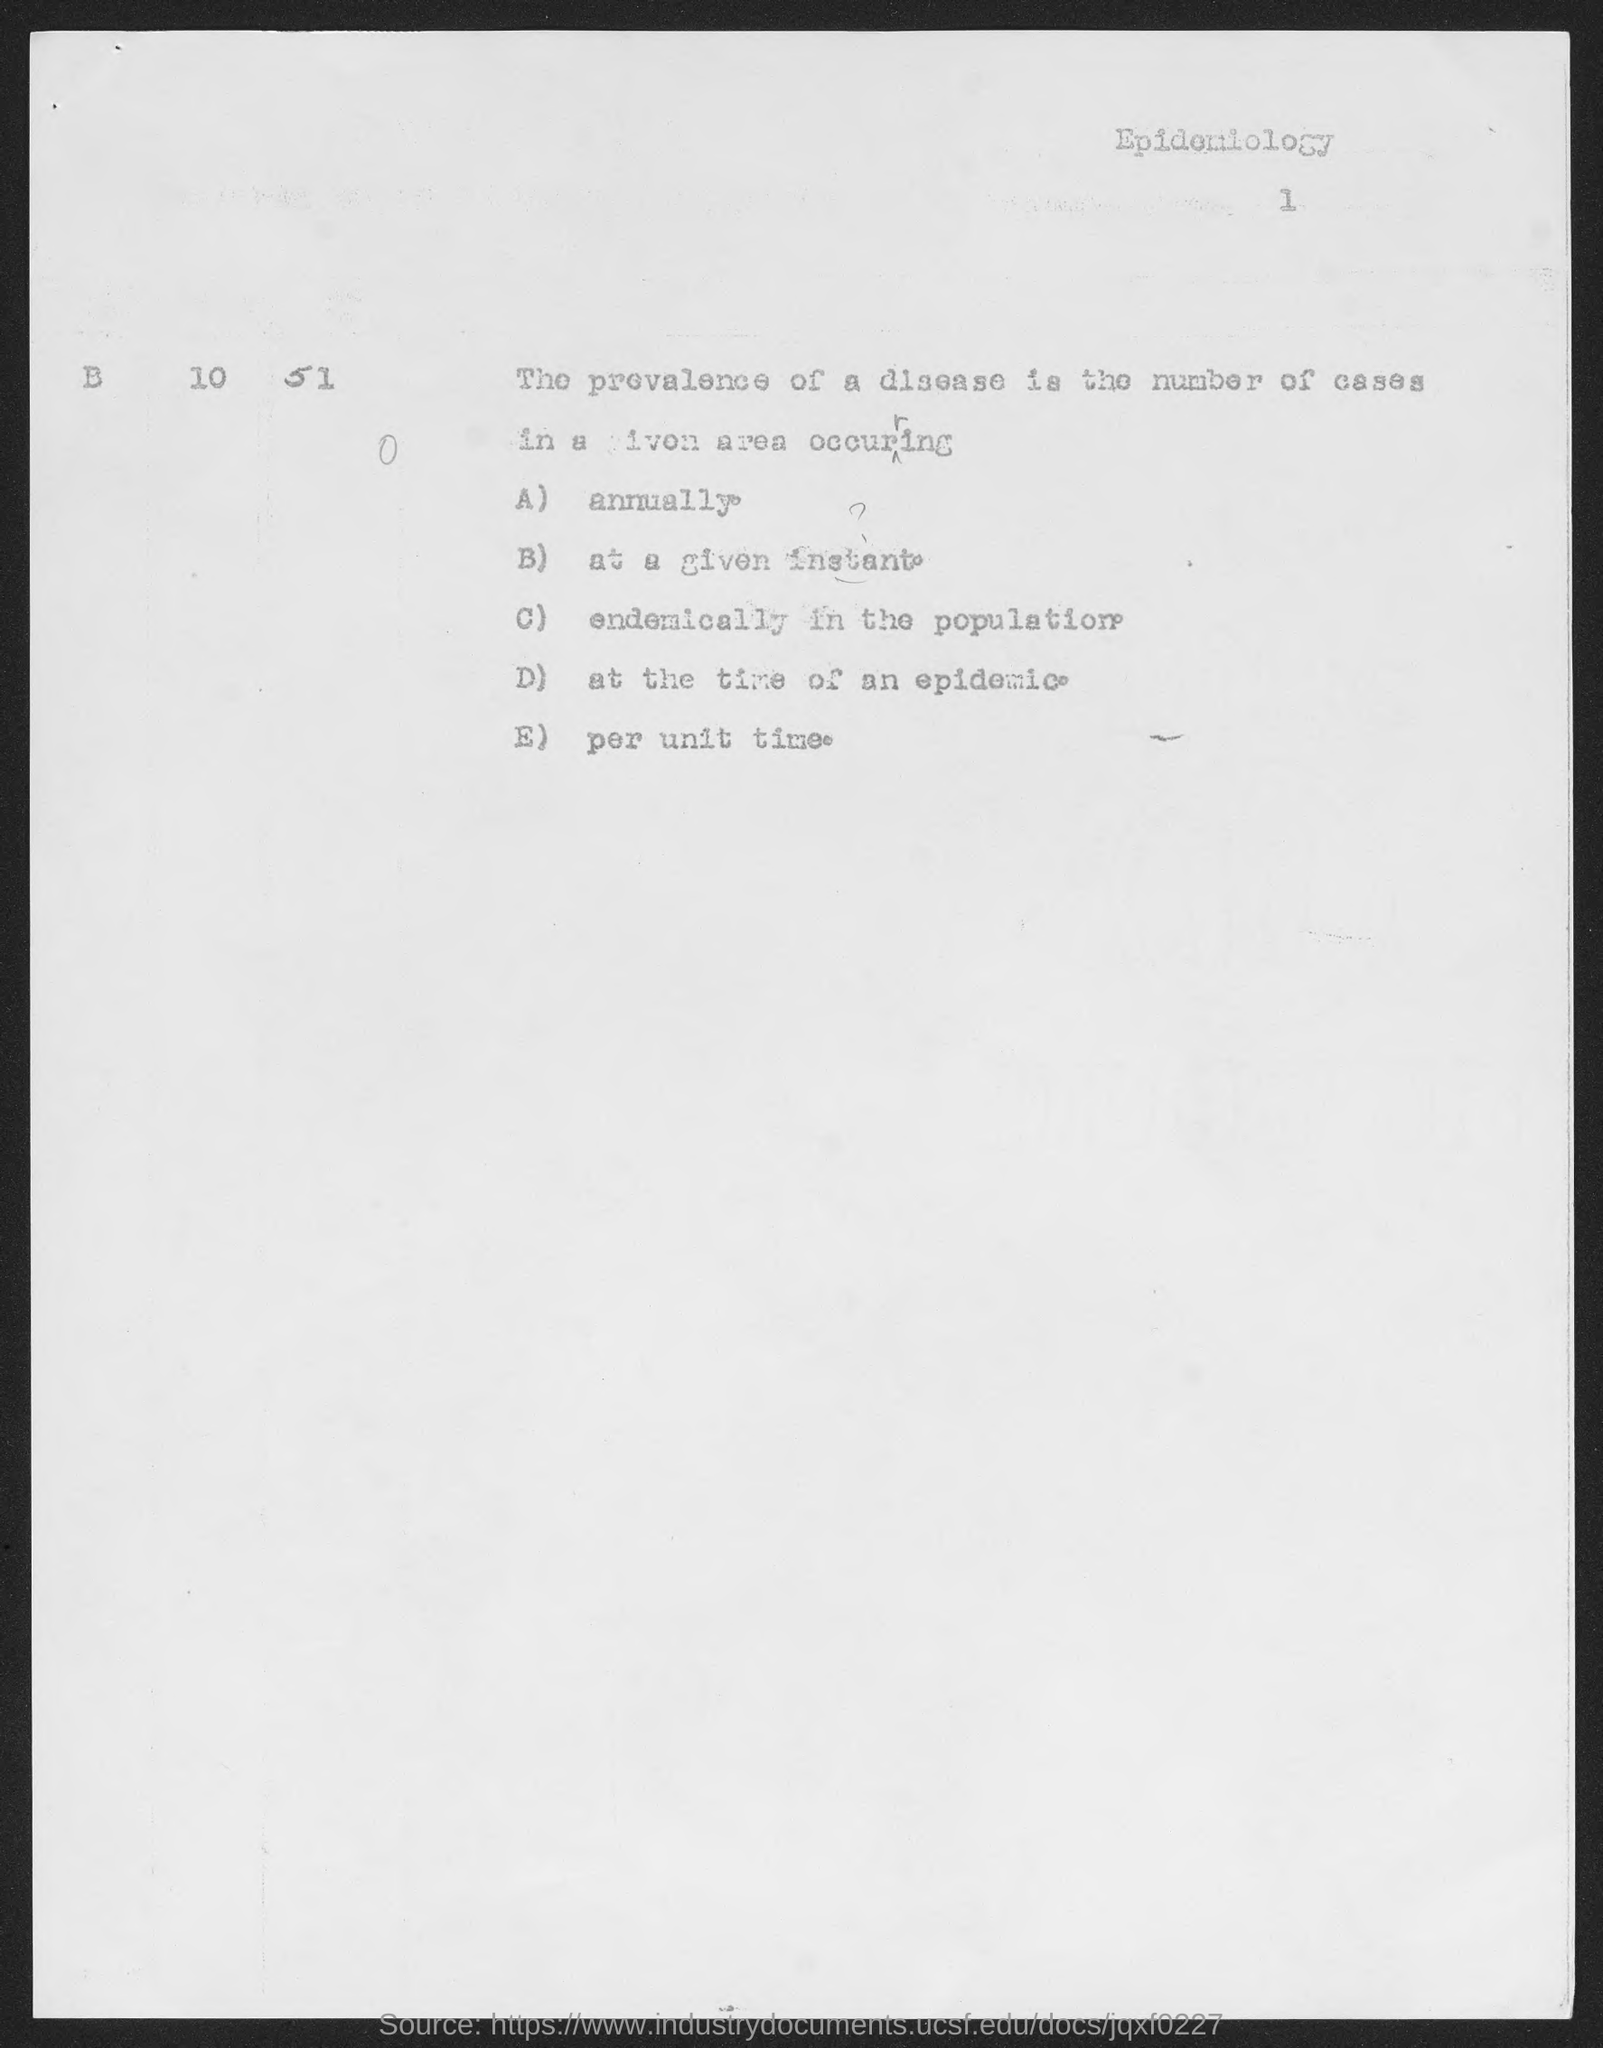What is option 'a'?
Make the answer very short. Annually. What is the subject name mentioned at the top right corner?
Make the answer very short. Epidemiology. What is the page number?
Make the answer very short. 1. 